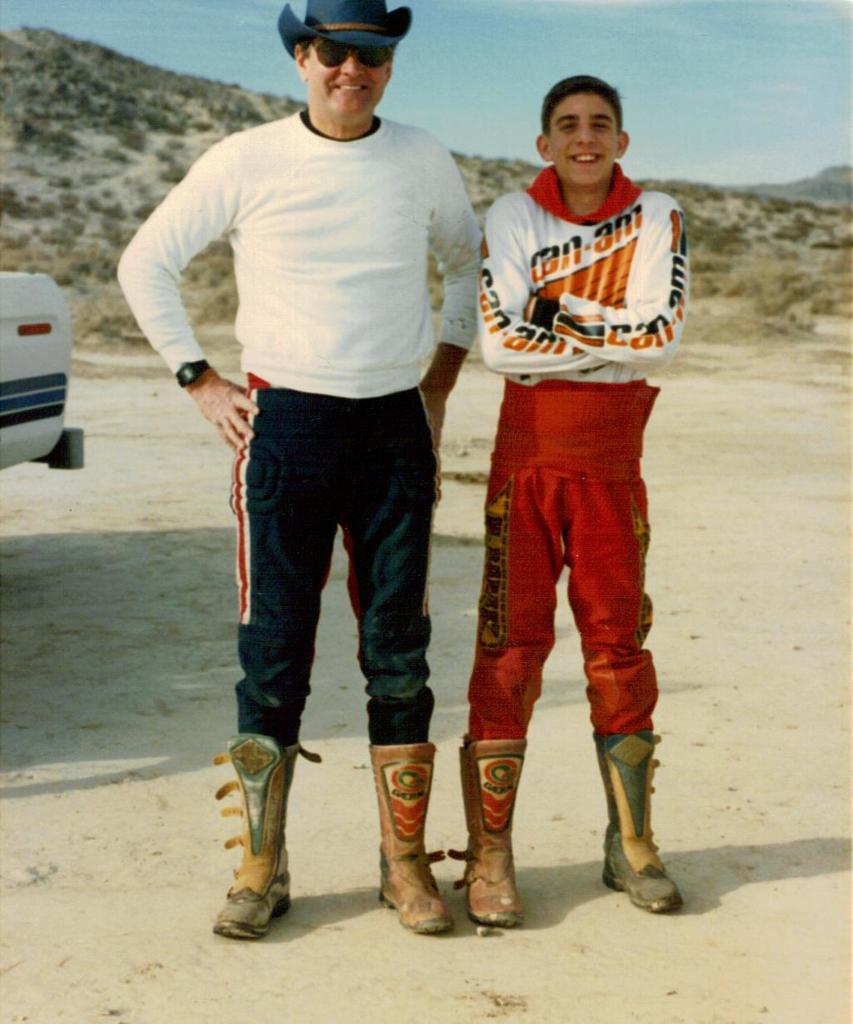<image>
Share a concise interpretation of the image provided. A boy wears a uniform with Can-Am on the front and the sleeves. 